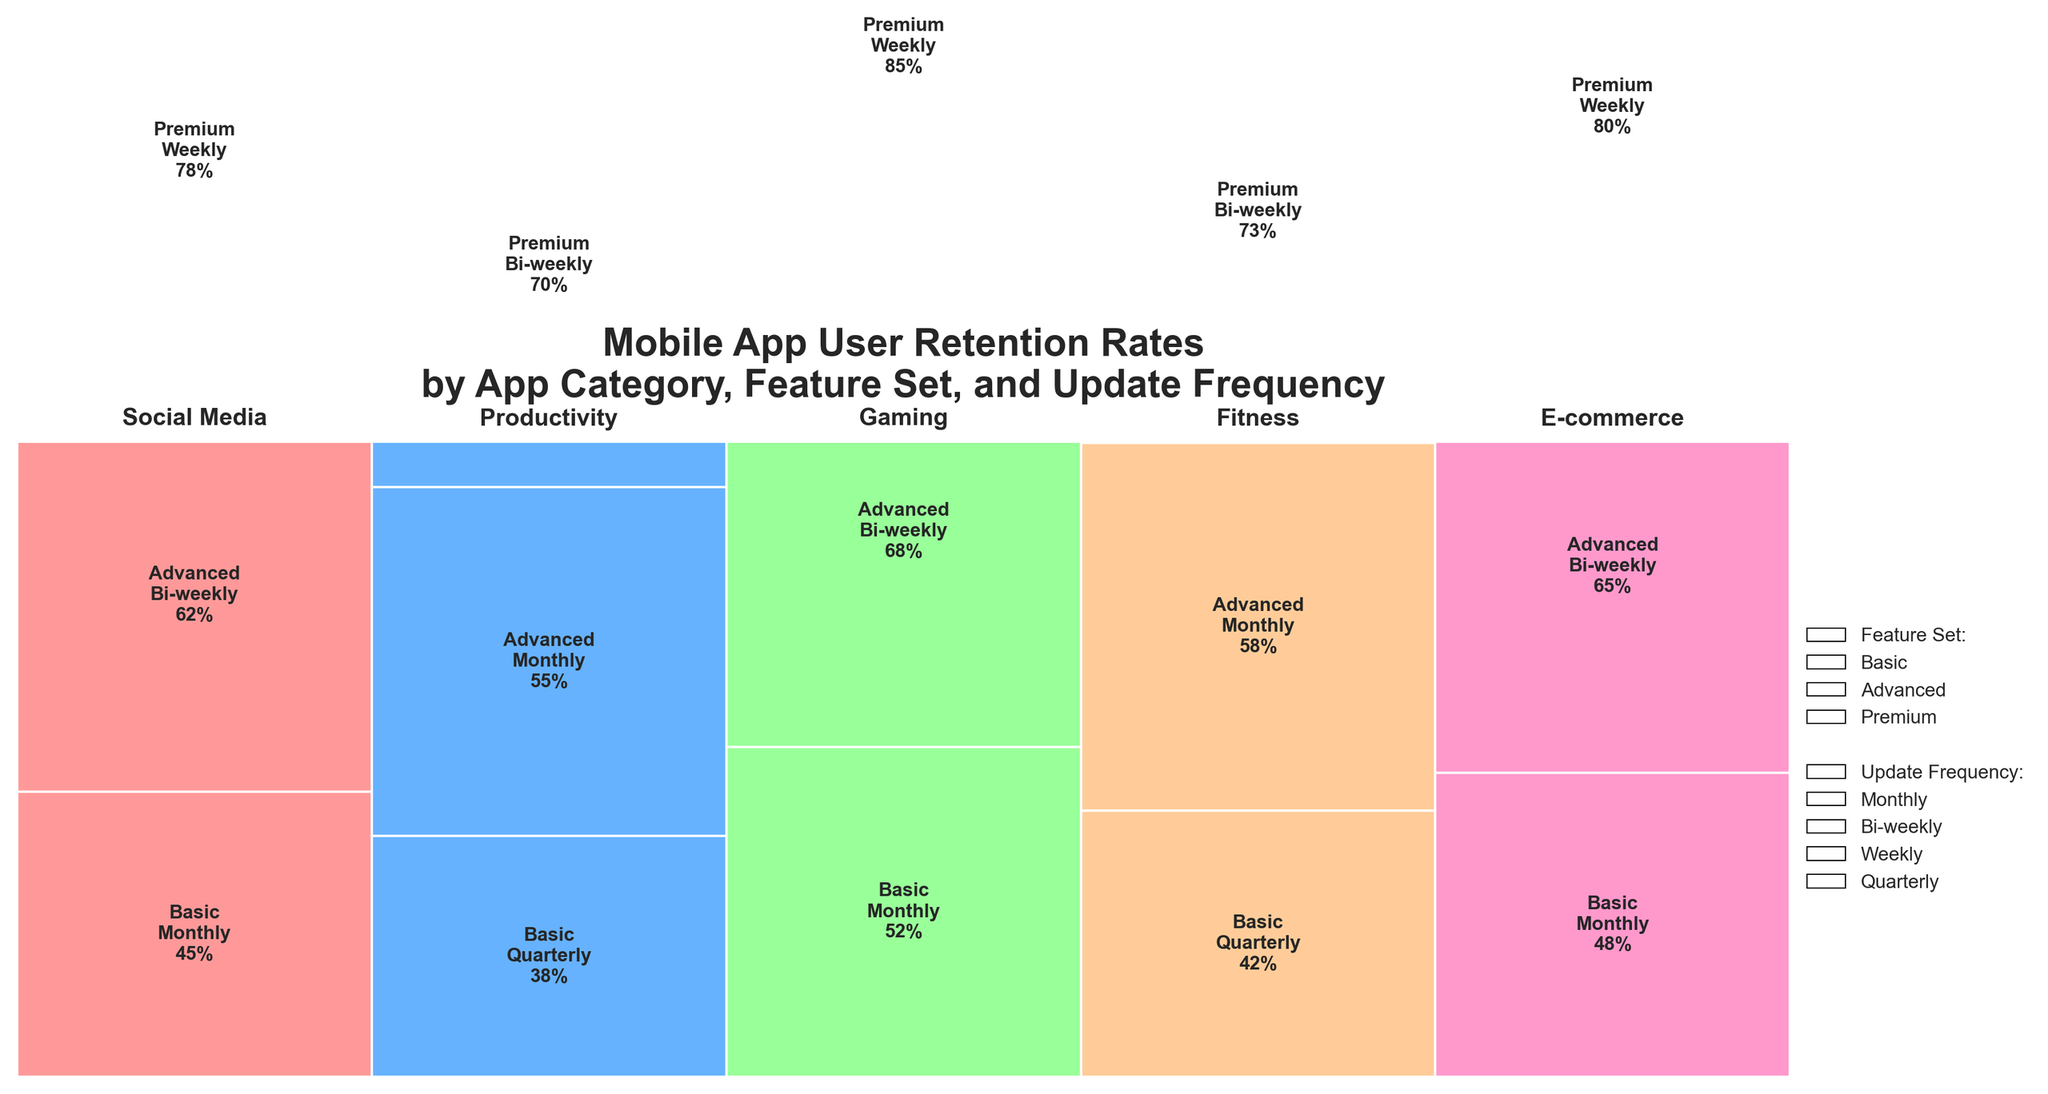Which app category has the highest retention rate? The highest retention rate can be observed from the complete height of the category stacked boxes. Fitness shows the highest block, with its premium feature and bi-weekly updates reaching 73%.
Answer: Fitness How much higher is the retention rate of social media with premium features compared to basic features? In social media, the retention rate of premium features is 78%, while for basic features it is 45%. To find the difference, subtract 45 from 78.
Answer: 33% What is the average user retention rate for e-commerce apps across all features and update frequencies? E-commerce has three feature sets with retention rates of 48% (Basic), 65% (Advanced), and 80% (Premium). The average is calculated by adding these rates and dividing by the number of features: (48 + 65 + 80)/3.
Answer: 64.33% Do productivity apps with advanced features outperform fitness apps with basic features? Compare the retention rate of productivity apps with advanced features (55%) against fitness apps with basic features (42%), and observe that 55% is indeed higher than 42%.
Answer: Yes Which feature set and update frequency combination shows the lowest user retention rate? By observing the smallest height block in the mosaic plot, productivity apps with basic features and quarterly updates have the lowest retention rate of 38%.
Answer: Basic features with quarterly updates in productivity apps How does the retention rate of gaming apps with advanced features compare to the retention rate of productivity apps with premium features? Gaming apps with advanced features have a retention rate of 68%, while productivity apps with premium features have a retention rate of 70%. The comparison shows that 68% is just slightly lower than 70%.
Answer: Slightly lower Are social media apps more likely to retain users with bi-weekly updates compared to monthly updates? Compare the retention rates of social media apps with bi-weekly updates (62%) to monthly updates (45%). Since 62% is higher than 45%, bi-weekly updates retain more users.
Answer: Yes Which app category under premium features has the highest retention rate? By looking at the highest block among premium features, the gaming category has the highest retention rate of 85%.
Answer: Gaming What percentage of total retention does the gaming category contribute with its weekly update, premium feature combination? Identify the retention rate of the gaming premium feature with weekly updates (85%). Since the question does not specify aggregating across all app categories, the percentage remains as observed.
Answer: 85% Do e-commerce apps with advanced features update more frequently than productivity apps with advanced features? E-commerce apps with advanced features have bi-weekly updates, while productivity apps with advanced features have monthly updates. Bi-weekly is more frequent than monthly.
Answer: Yes 